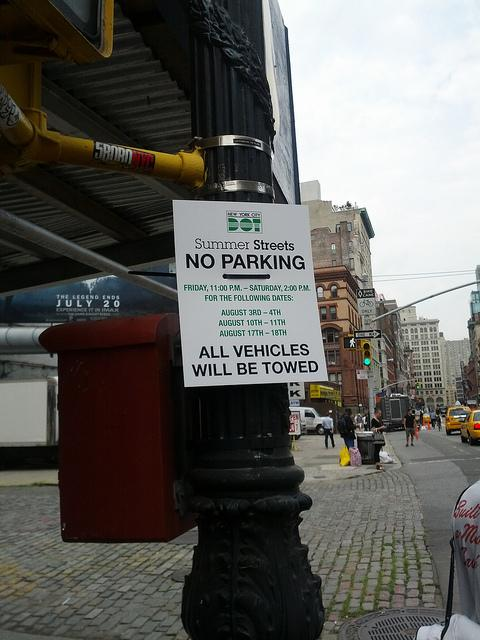What is the green on the bricks on the ground? moss 